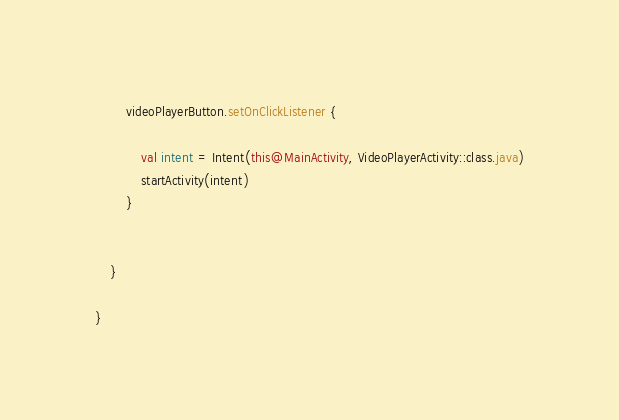<code> <loc_0><loc_0><loc_500><loc_500><_Kotlin_>        videoPlayerButton.setOnClickListener {

            val intent = Intent(this@MainActivity, VideoPlayerActivity::class.java)
            startActivity(intent)
        }


    }

}

</code> 